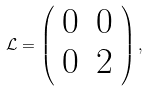<formula> <loc_0><loc_0><loc_500><loc_500>\mathcal { L } = \left ( \begin{array} { c c } 0 & 0 \\ 0 & 2 \\ \end{array} \right ) ,</formula> 